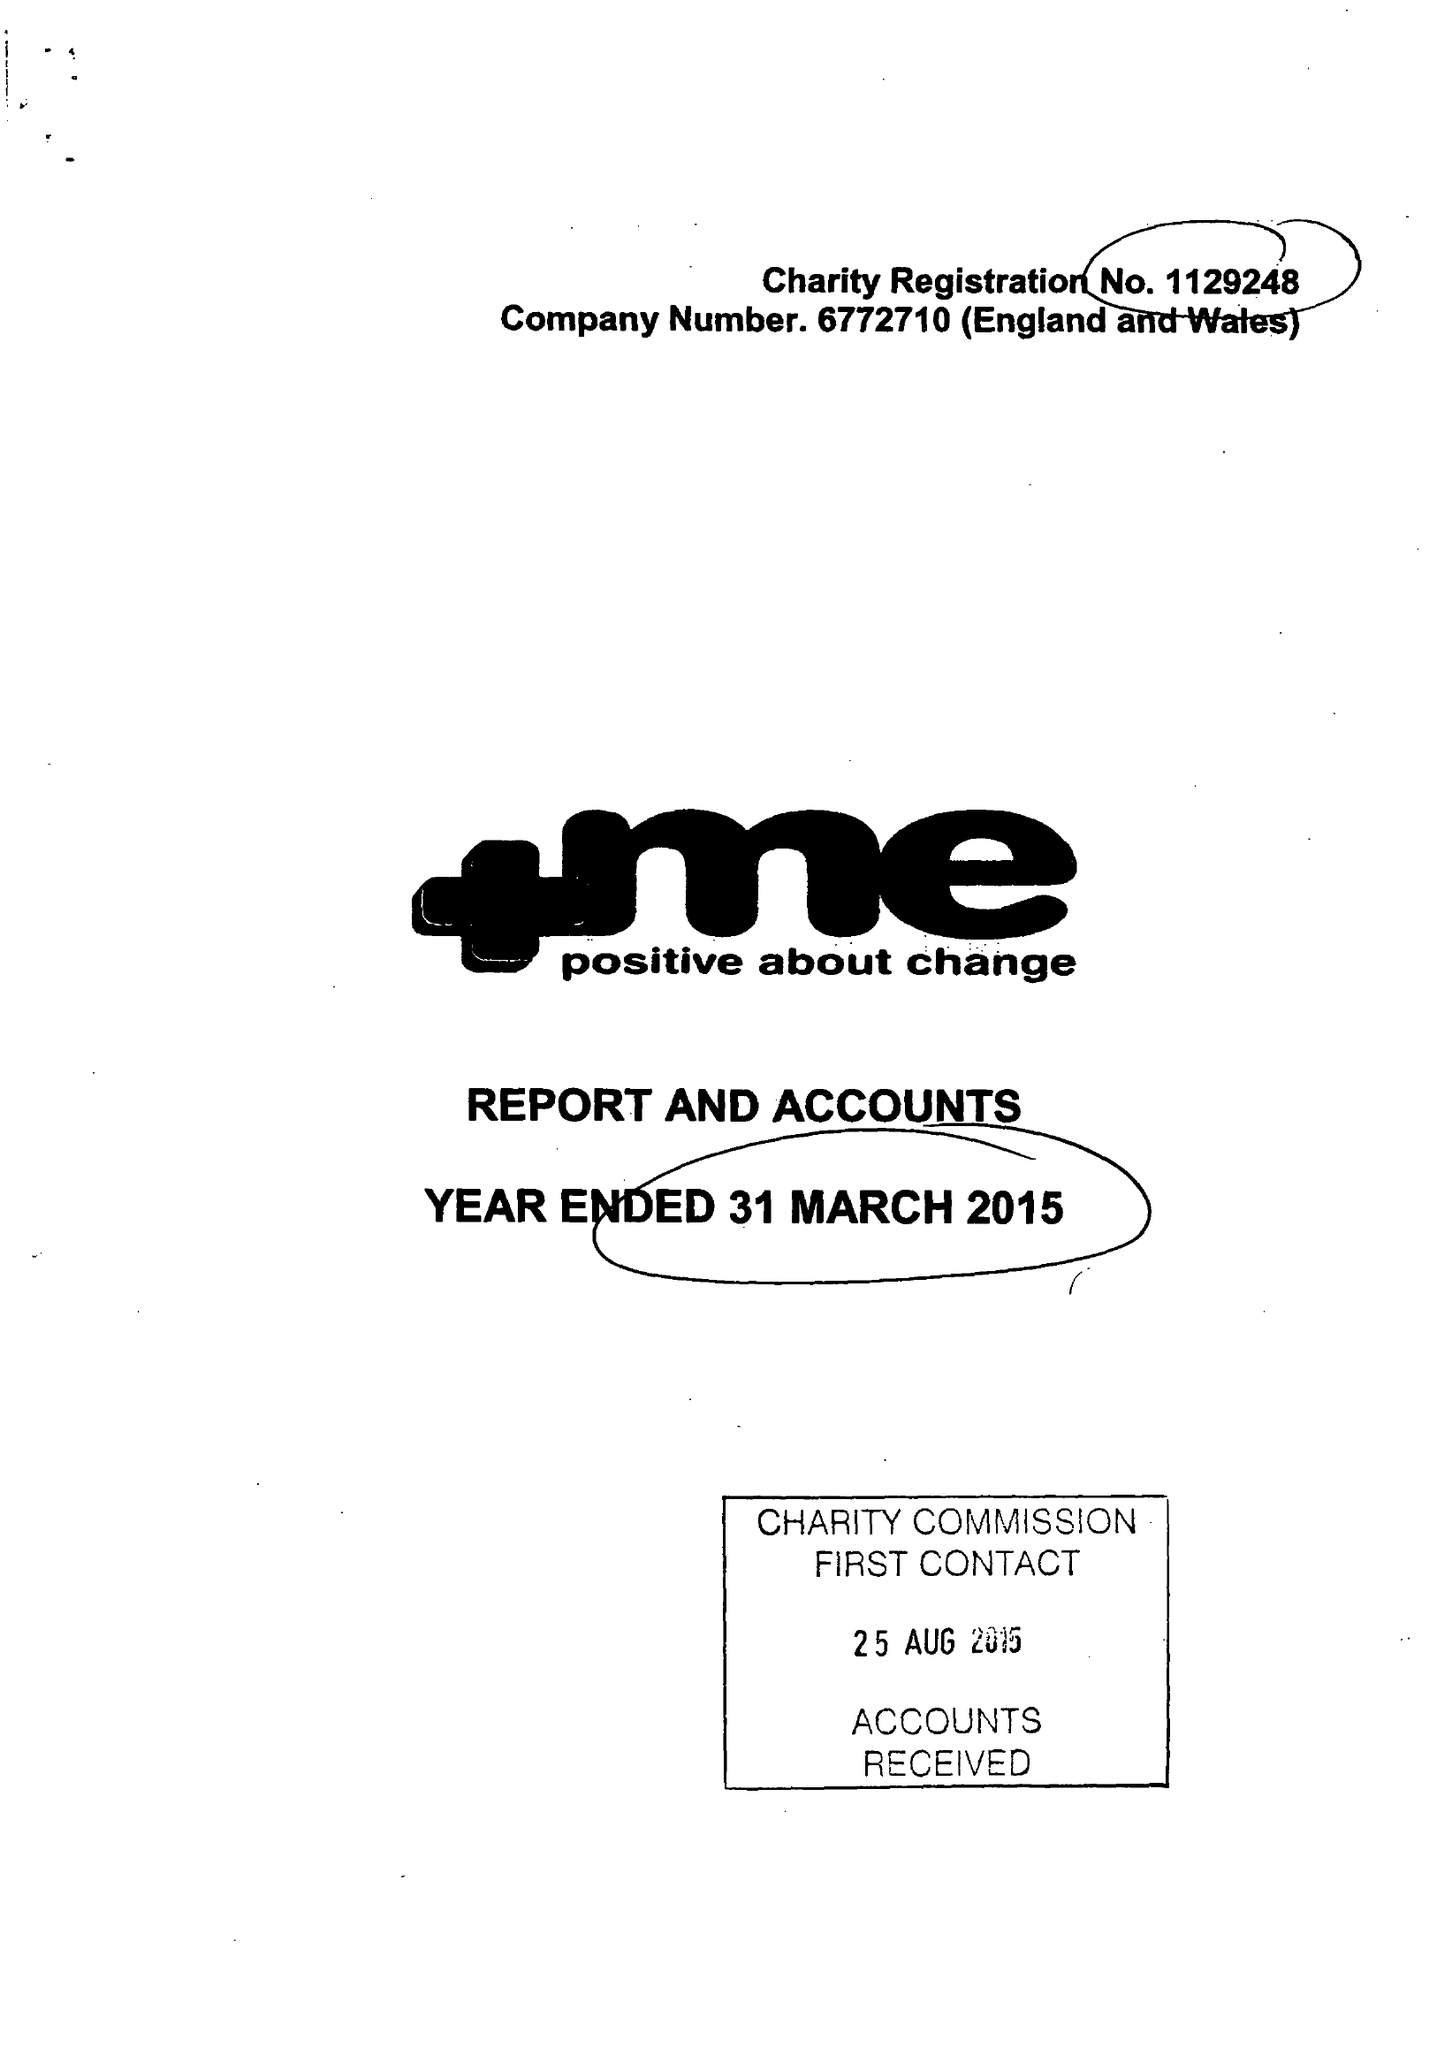What is the value for the report_date?
Answer the question using a single word or phrase. 2015-03-31 